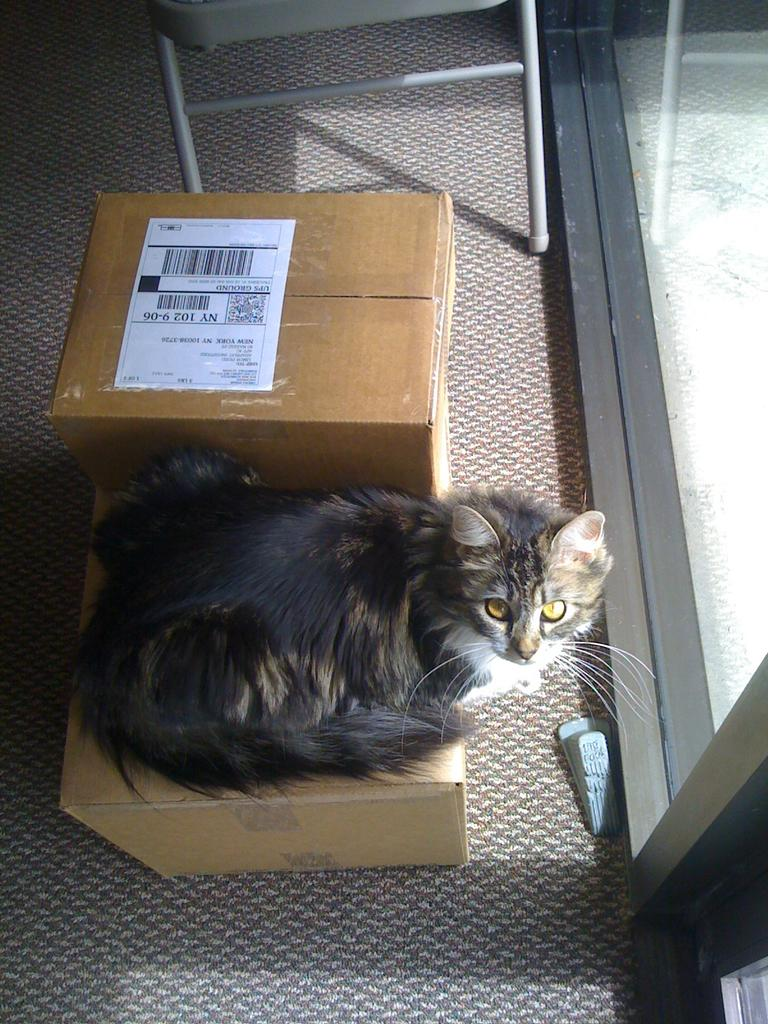What animal is present in the image? There is a cat in the image. Where is the cat sitting? The cat is sitting on a cardboard box. What colors can be seen on the cat? The cat is black and brown in color. What is attached to the cardboard box? There is paper attached to the cardboard box. What type of door is in front of the cardboard box? There is a glass door in front of the cardboard box. What piece of furniture is in front of the glass door? There is a chair in front of the glass door. What is the value of the root in the image? There is no root present in the image, so it is not possible to determine its value. 